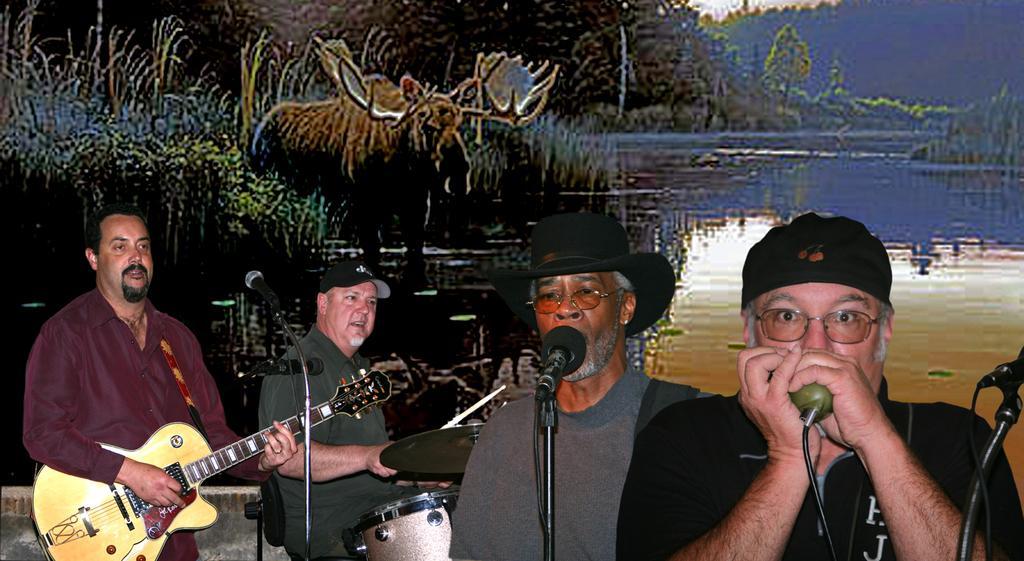Can you describe this image briefly? There are four people in the image who are standing and playing their musical instruments. In middle there is a man who is wearing black color hat standing in front of a microphone and singing. In background we can see lake,trees,bird and sky is on top. 